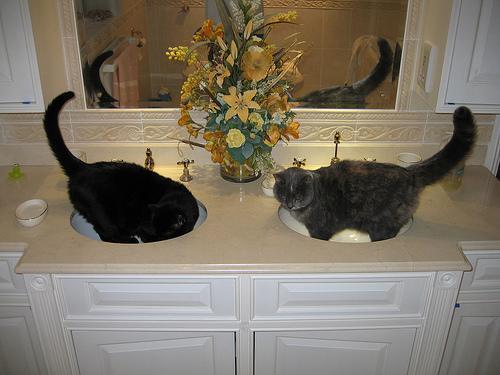How many cats are there?
Give a very brief answer. 2. 